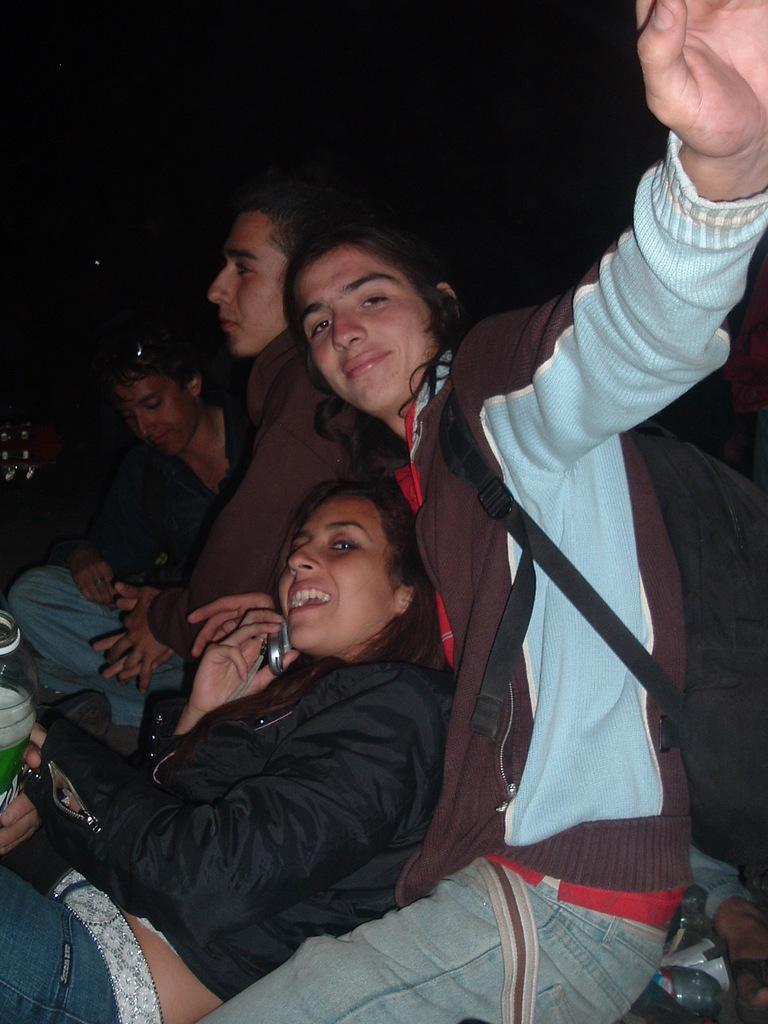What is the general activity of the people in the image? There is a group of people sitting in the image. Can you describe any specific items that one person in the group is carrying? One person in the group is carrying a backpack. What object is being held by another person in the group? One person in the group is holding a mobile. What might the person holding the bottle be drinking? The person holding the bottle might be drinking water or another beverage. What type of twig is being used as a prop in the image? There is no twig present in the image. How many dimes can be seen on the table in the image? There are no dimes visible in the image. 